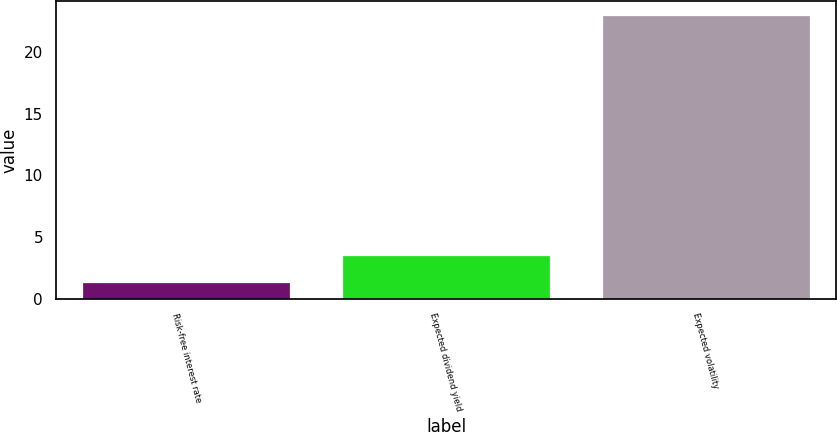Convert chart. <chart><loc_0><loc_0><loc_500><loc_500><bar_chart><fcel>Risk-free interest rate<fcel>Expected dividend yield<fcel>Expected volatility<nl><fcel>1.34<fcel>3.51<fcel>23<nl></chart> 